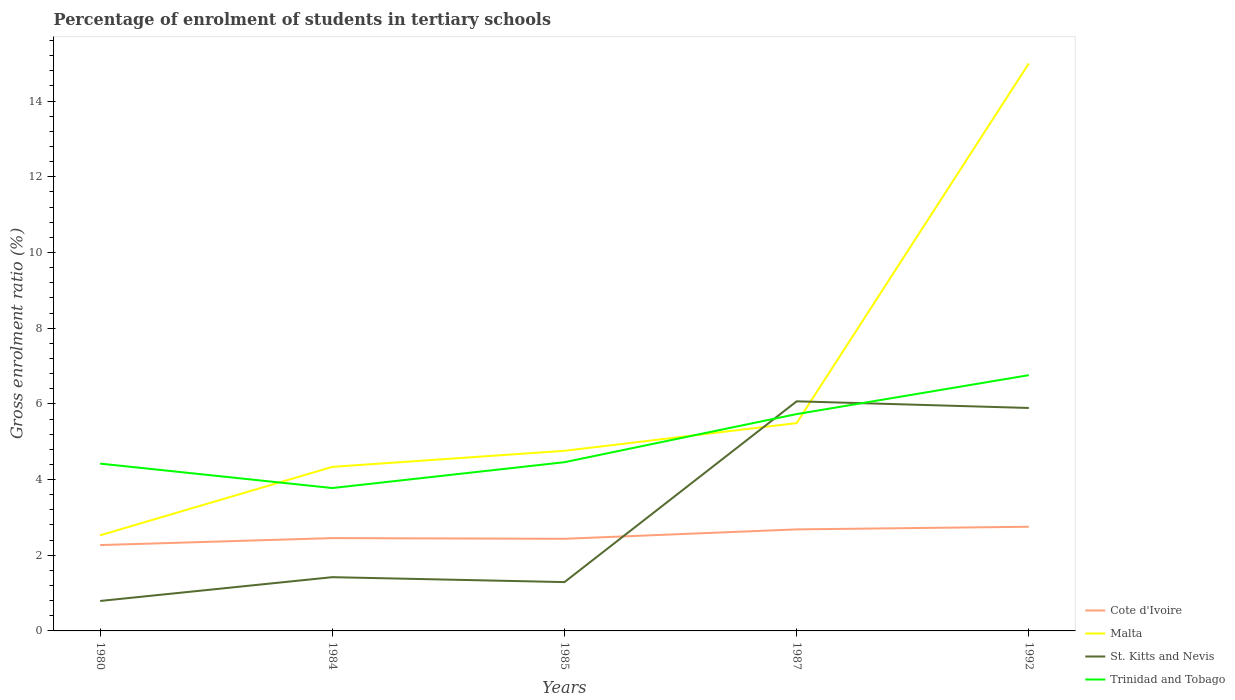How many different coloured lines are there?
Make the answer very short. 4. Does the line corresponding to St. Kitts and Nevis intersect with the line corresponding to Trinidad and Tobago?
Your answer should be very brief. Yes. Across all years, what is the maximum percentage of students enrolled in tertiary schools in St. Kitts and Nevis?
Your answer should be compact. 0.79. In which year was the percentage of students enrolled in tertiary schools in Trinidad and Tobago maximum?
Make the answer very short. 1984. What is the total percentage of students enrolled in tertiary schools in Cote d'Ivoire in the graph?
Provide a short and direct response. -0.18. What is the difference between the highest and the second highest percentage of students enrolled in tertiary schools in St. Kitts and Nevis?
Your answer should be compact. 5.28. What is the difference between the highest and the lowest percentage of students enrolled in tertiary schools in Trinidad and Tobago?
Make the answer very short. 2. How many lines are there?
Your response must be concise. 4. What is the difference between two consecutive major ticks on the Y-axis?
Your answer should be compact. 2. Does the graph contain any zero values?
Offer a very short reply. No. Does the graph contain grids?
Ensure brevity in your answer.  No. How many legend labels are there?
Provide a short and direct response. 4. How are the legend labels stacked?
Your answer should be compact. Vertical. What is the title of the graph?
Offer a terse response. Percentage of enrolment of students in tertiary schools. Does "Gabon" appear as one of the legend labels in the graph?
Give a very brief answer. No. What is the label or title of the X-axis?
Give a very brief answer. Years. What is the Gross enrolment ratio (%) of Cote d'Ivoire in 1980?
Give a very brief answer. 2.27. What is the Gross enrolment ratio (%) of Malta in 1980?
Provide a succinct answer. 2.53. What is the Gross enrolment ratio (%) of St. Kitts and Nevis in 1980?
Your answer should be compact. 0.79. What is the Gross enrolment ratio (%) in Trinidad and Tobago in 1980?
Ensure brevity in your answer.  4.42. What is the Gross enrolment ratio (%) in Cote d'Ivoire in 1984?
Give a very brief answer. 2.45. What is the Gross enrolment ratio (%) of Malta in 1984?
Ensure brevity in your answer.  4.33. What is the Gross enrolment ratio (%) of St. Kitts and Nevis in 1984?
Keep it short and to the point. 1.42. What is the Gross enrolment ratio (%) of Trinidad and Tobago in 1984?
Provide a succinct answer. 3.78. What is the Gross enrolment ratio (%) in Cote d'Ivoire in 1985?
Give a very brief answer. 2.43. What is the Gross enrolment ratio (%) of Malta in 1985?
Your response must be concise. 4.76. What is the Gross enrolment ratio (%) of St. Kitts and Nevis in 1985?
Provide a short and direct response. 1.29. What is the Gross enrolment ratio (%) in Trinidad and Tobago in 1985?
Your response must be concise. 4.46. What is the Gross enrolment ratio (%) of Cote d'Ivoire in 1987?
Keep it short and to the point. 2.68. What is the Gross enrolment ratio (%) of Malta in 1987?
Ensure brevity in your answer.  5.49. What is the Gross enrolment ratio (%) in St. Kitts and Nevis in 1987?
Keep it short and to the point. 6.07. What is the Gross enrolment ratio (%) of Trinidad and Tobago in 1987?
Provide a succinct answer. 5.73. What is the Gross enrolment ratio (%) in Cote d'Ivoire in 1992?
Offer a terse response. 2.75. What is the Gross enrolment ratio (%) in Malta in 1992?
Give a very brief answer. 15. What is the Gross enrolment ratio (%) of St. Kitts and Nevis in 1992?
Offer a very short reply. 5.89. What is the Gross enrolment ratio (%) of Trinidad and Tobago in 1992?
Your answer should be compact. 6.76. Across all years, what is the maximum Gross enrolment ratio (%) of Cote d'Ivoire?
Offer a terse response. 2.75. Across all years, what is the maximum Gross enrolment ratio (%) in Malta?
Offer a terse response. 15. Across all years, what is the maximum Gross enrolment ratio (%) in St. Kitts and Nevis?
Give a very brief answer. 6.07. Across all years, what is the maximum Gross enrolment ratio (%) in Trinidad and Tobago?
Provide a succinct answer. 6.76. Across all years, what is the minimum Gross enrolment ratio (%) in Cote d'Ivoire?
Your answer should be compact. 2.27. Across all years, what is the minimum Gross enrolment ratio (%) in Malta?
Give a very brief answer. 2.53. Across all years, what is the minimum Gross enrolment ratio (%) in St. Kitts and Nevis?
Provide a succinct answer. 0.79. Across all years, what is the minimum Gross enrolment ratio (%) in Trinidad and Tobago?
Keep it short and to the point. 3.78. What is the total Gross enrolment ratio (%) of Cote d'Ivoire in the graph?
Provide a succinct answer. 12.59. What is the total Gross enrolment ratio (%) in Malta in the graph?
Your answer should be compact. 32.11. What is the total Gross enrolment ratio (%) in St. Kitts and Nevis in the graph?
Your answer should be very brief. 15.46. What is the total Gross enrolment ratio (%) in Trinidad and Tobago in the graph?
Your answer should be compact. 25.14. What is the difference between the Gross enrolment ratio (%) in Cote d'Ivoire in 1980 and that in 1984?
Give a very brief answer. -0.18. What is the difference between the Gross enrolment ratio (%) in Malta in 1980 and that in 1984?
Make the answer very short. -1.81. What is the difference between the Gross enrolment ratio (%) of St. Kitts and Nevis in 1980 and that in 1984?
Ensure brevity in your answer.  -0.63. What is the difference between the Gross enrolment ratio (%) of Trinidad and Tobago in 1980 and that in 1984?
Your answer should be very brief. 0.65. What is the difference between the Gross enrolment ratio (%) of Cote d'Ivoire in 1980 and that in 1985?
Your response must be concise. -0.17. What is the difference between the Gross enrolment ratio (%) in Malta in 1980 and that in 1985?
Give a very brief answer. -2.23. What is the difference between the Gross enrolment ratio (%) in St. Kitts and Nevis in 1980 and that in 1985?
Provide a succinct answer. -0.5. What is the difference between the Gross enrolment ratio (%) in Trinidad and Tobago in 1980 and that in 1985?
Ensure brevity in your answer.  -0.04. What is the difference between the Gross enrolment ratio (%) in Cote d'Ivoire in 1980 and that in 1987?
Give a very brief answer. -0.41. What is the difference between the Gross enrolment ratio (%) in Malta in 1980 and that in 1987?
Provide a succinct answer. -2.96. What is the difference between the Gross enrolment ratio (%) in St. Kitts and Nevis in 1980 and that in 1987?
Give a very brief answer. -5.28. What is the difference between the Gross enrolment ratio (%) of Trinidad and Tobago in 1980 and that in 1987?
Your answer should be very brief. -1.31. What is the difference between the Gross enrolment ratio (%) in Cote d'Ivoire in 1980 and that in 1992?
Make the answer very short. -0.48. What is the difference between the Gross enrolment ratio (%) in Malta in 1980 and that in 1992?
Offer a terse response. -12.47. What is the difference between the Gross enrolment ratio (%) of Trinidad and Tobago in 1980 and that in 1992?
Your answer should be compact. -2.34. What is the difference between the Gross enrolment ratio (%) in Cote d'Ivoire in 1984 and that in 1985?
Offer a very short reply. 0.02. What is the difference between the Gross enrolment ratio (%) of Malta in 1984 and that in 1985?
Ensure brevity in your answer.  -0.42. What is the difference between the Gross enrolment ratio (%) in St. Kitts and Nevis in 1984 and that in 1985?
Your answer should be very brief. 0.13. What is the difference between the Gross enrolment ratio (%) in Trinidad and Tobago in 1984 and that in 1985?
Your answer should be compact. -0.68. What is the difference between the Gross enrolment ratio (%) of Cote d'Ivoire in 1984 and that in 1987?
Keep it short and to the point. -0.23. What is the difference between the Gross enrolment ratio (%) in Malta in 1984 and that in 1987?
Your answer should be compact. -1.16. What is the difference between the Gross enrolment ratio (%) of St. Kitts and Nevis in 1984 and that in 1987?
Your answer should be compact. -4.65. What is the difference between the Gross enrolment ratio (%) of Trinidad and Tobago in 1984 and that in 1987?
Your answer should be very brief. -1.95. What is the difference between the Gross enrolment ratio (%) of Cote d'Ivoire in 1984 and that in 1992?
Ensure brevity in your answer.  -0.3. What is the difference between the Gross enrolment ratio (%) in Malta in 1984 and that in 1992?
Your answer should be very brief. -10.66. What is the difference between the Gross enrolment ratio (%) in St. Kitts and Nevis in 1984 and that in 1992?
Offer a terse response. -4.47. What is the difference between the Gross enrolment ratio (%) in Trinidad and Tobago in 1984 and that in 1992?
Ensure brevity in your answer.  -2.98. What is the difference between the Gross enrolment ratio (%) of Cote d'Ivoire in 1985 and that in 1987?
Ensure brevity in your answer.  -0.25. What is the difference between the Gross enrolment ratio (%) in Malta in 1985 and that in 1987?
Ensure brevity in your answer.  -0.73. What is the difference between the Gross enrolment ratio (%) in St. Kitts and Nevis in 1985 and that in 1987?
Offer a terse response. -4.78. What is the difference between the Gross enrolment ratio (%) of Trinidad and Tobago in 1985 and that in 1987?
Provide a short and direct response. -1.27. What is the difference between the Gross enrolment ratio (%) of Cote d'Ivoire in 1985 and that in 1992?
Your response must be concise. -0.32. What is the difference between the Gross enrolment ratio (%) in Malta in 1985 and that in 1992?
Your response must be concise. -10.24. What is the difference between the Gross enrolment ratio (%) of St. Kitts and Nevis in 1985 and that in 1992?
Your response must be concise. -4.6. What is the difference between the Gross enrolment ratio (%) in Trinidad and Tobago in 1985 and that in 1992?
Keep it short and to the point. -2.3. What is the difference between the Gross enrolment ratio (%) of Cote d'Ivoire in 1987 and that in 1992?
Ensure brevity in your answer.  -0.07. What is the difference between the Gross enrolment ratio (%) of Malta in 1987 and that in 1992?
Your answer should be very brief. -9.5. What is the difference between the Gross enrolment ratio (%) in St. Kitts and Nevis in 1987 and that in 1992?
Provide a succinct answer. 0.18. What is the difference between the Gross enrolment ratio (%) in Trinidad and Tobago in 1987 and that in 1992?
Offer a very short reply. -1.03. What is the difference between the Gross enrolment ratio (%) of Cote d'Ivoire in 1980 and the Gross enrolment ratio (%) of Malta in 1984?
Keep it short and to the point. -2.07. What is the difference between the Gross enrolment ratio (%) in Cote d'Ivoire in 1980 and the Gross enrolment ratio (%) in St. Kitts and Nevis in 1984?
Provide a short and direct response. 0.85. What is the difference between the Gross enrolment ratio (%) of Cote d'Ivoire in 1980 and the Gross enrolment ratio (%) of Trinidad and Tobago in 1984?
Ensure brevity in your answer.  -1.51. What is the difference between the Gross enrolment ratio (%) in Malta in 1980 and the Gross enrolment ratio (%) in St. Kitts and Nevis in 1984?
Your response must be concise. 1.11. What is the difference between the Gross enrolment ratio (%) in Malta in 1980 and the Gross enrolment ratio (%) in Trinidad and Tobago in 1984?
Give a very brief answer. -1.25. What is the difference between the Gross enrolment ratio (%) of St. Kitts and Nevis in 1980 and the Gross enrolment ratio (%) of Trinidad and Tobago in 1984?
Keep it short and to the point. -2.98. What is the difference between the Gross enrolment ratio (%) of Cote d'Ivoire in 1980 and the Gross enrolment ratio (%) of Malta in 1985?
Your answer should be compact. -2.49. What is the difference between the Gross enrolment ratio (%) in Cote d'Ivoire in 1980 and the Gross enrolment ratio (%) in St. Kitts and Nevis in 1985?
Provide a short and direct response. 0.98. What is the difference between the Gross enrolment ratio (%) in Cote d'Ivoire in 1980 and the Gross enrolment ratio (%) in Trinidad and Tobago in 1985?
Offer a very short reply. -2.19. What is the difference between the Gross enrolment ratio (%) in Malta in 1980 and the Gross enrolment ratio (%) in St. Kitts and Nevis in 1985?
Offer a very short reply. 1.24. What is the difference between the Gross enrolment ratio (%) in Malta in 1980 and the Gross enrolment ratio (%) in Trinidad and Tobago in 1985?
Your answer should be compact. -1.93. What is the difference between the Gross enrolment ratio (%) in St. Kitts and Nevis in 1980 and the Gross enrolment ratio (%) in Trinidad and Tobago in 1985?
Your answer should be very brief. -3.67. What is the difference between the Gross enrolment ratio (%) of Cote d'Ivoire in 1980 and the Gross enrolment ratio (%) of Malta in 1987?
Your answer should be compact. -3.22. What is the difference between the Gross enrolment ratio (%) in Cote d'Ivoire in 1980 and the Gross enrolment ratio (%) in St. Kitts and Nevis in 1987?
Your response must be concise. -3.8. What is the difference between the Gross enrolment ratio (%) of Cote d'Ivoire in 1980 and the Gross enrolment ratio (%) of Trinidad and Tobago in 1987?
Offer a terse response. -3.46. What is the difference between the Gross enrolment ratio (%) of Malta in 1980 and the Gross enrolment ratio (%) of St. Kitts and Nevis in 1987?
Your response must be concise. -3.54. What is the difference between the Gross enrolment ratio (%) of Malta in 1980 and the Gross enrolment ratio (%) of Trinidad and Tobago in 1987?
Ensure brevity in your answer.  -3.2. What is the difference between the Gross enrolment ratio (%) of St. Kitts and Nevis in 1980 and the Gross enrolment ratio (%) of Trinidad and Tobago in 1987?
Your response must be concise. -4.94. What is the difference between the Gross enrolment ratio (%) of Cote d'Ivoire in 1980 and the Gross enrolment ratio (%) of Malta in 1992?
Your response must be concise. -12.73. What is the difference between the Gross enrolment ratio (%) in Cote d'Ivoire in 1980 and the Gross enrolment ratio (%) in St. Kitts and Nevis in 1992?
Make the answer very short. -3.62. What is the difference between the Gross enrolment ratio (%) of Cote d'Ivoire in 1980 and the Gross enrolment ratio (%) of Trinidad and Tobago in 1992?
Provide a succinct answer. -4.49. What is the difference between the Gross enrolment ratio (%) in Malta in 1980 and the Gross enrolment ratio (%) in St. Kitts and Nevis in 1992?
Ensure brevity in your answer.  -3.36. What is the difference between the Gross enrolment ratio (%) of Malta in 1980 and the Gross enrolment ratio (%) of Trinidad and Tobago in 1992?
Provide a succinct answer. -4.23. What is the difference between the Gross enrolment ratio (%) in St. Kitts and Nevis in 1980 and the Gross enrolment ratio (%) in Trinidad and Tobago in 1992?
Your answer should be very brief. -5.97. What is the difference between the Gross enrolment ratio (%) of Cote d'Ivoire in 1984 and the Gross enrolment ratio (%) of Malta in 1985?
Give a very brief answer. -2.31. What is the difference between the Gross enrolment ratio (%) of Cote d'Ivoire in 1984 and the Gross enrolment ratio (%) of St. Kitts and Nevis in 1985?
Your answer should be compact. 1.16. What is the difference between the Gross enrolment ratio (%) of Cote d'Ivoire in 1984 and the Gross enrolment ratio (%) of Trinidad and Tobago in 1985?
Make the answer very short. -2.01. What is the difference between the Gross enrolment ratio (%) in Malta in 1984 and the Gross enrolment ratio (%) in St. Kitts and Nevis in 1985?
Provide a short and direct response. 3.04. What is the difference between the Gross enrolment ratio (%) of Malta in 1984 and the Gross enrolment ratio (%) of Trinidad and Tobago in 1985?
Your answer should be compact. -0.12. What is the difference between the Gross enrolment ratio (%) of St. Kitts and Nevis in 1984 and the Gross enrolment ratio (%) of Trinidad and Tobago in 1985?
Provide a succinct answer. -3.04. What is the difference between the Gross enrolment ratio (%) of Cote d'Ivoire in 1984 and the Gross enrolment ratio (%) of Malta in 1987?
Make the answer very short. -3.04. What is the difference between the Gross enrolment ratio (%) of Cote d'Ivoire in 1984 and the Gross enrolment ratio (%) of St. Kitts and Nevis in 1987?
Your answer should be compact. -3.62. What is the difference between the Gross enrolment ratio (%) of Cote d'Ivoire in 1984 and the Gross enrolment ratio (%) of Trinidad and Tobago in 1987?
Give a very brief answer. -3.28. What is the difference between the Gross enrolment ratio (%) of Malta in 1984 and the Gross enrolment ratio (%) of St. Kitts and Nevis in 1987?
Your response must be concise. -1.73. What is the difference between the Gross enrolment ratio (%) of Malta in 1984 and the Gross enrolment ratio (%) of Trinidad and Tobago in 1987?
Your response must be concise. -1.39. What is the difference between the Gross enrolment ratio (%) in St. Kitts and Nevis in 1984 and the Gross enrolment ratio (%) in Trinidad and Tobago in 1987?
Your answer should be compact. -4.31. What is the difference between the Gross enrolment ratio (%) of Cote d'Ivoire in 1984 and the Gross enrolment ratio (%) of Malta in 1992?
Provide a short and direct response. -12.54. What is the difference between the Gross enrolment ratio (%) of Cote d'Ivoire in 1984 and the Gross enrolment ratio (%) of St. Kitts and Nevis in 1992?
Offer a very short reply. -3.44. What is the difference between the Gross enrolment ratio (%) of Cote d'Ivoire in 1984 and the Gross enrolment ratio (%) of Trinidad and Tobago in 1992?
Provide a short and direct response. -4.31. What is the difference between the Gross enrolment ratio (%) of Malta in 1984 and the Gross enrolment ratio (%) of St. Kitts and Nevis in 1992?
Provide a succinct answer. -1.56. What is the difference between the Gross enrolment ratio (%) in Malta in 1984 and the Gross enrolment ratio (%) in Trinidad and Tobago in 1992?
Offer a very short reply. -2.42. What is the difference between the Gross enrolment ratio (%) of St. Kitts and Nevis in 1984 and the Gross enrolment ratio (%) of Trinidad and Tobago in 1992?
Your answer should be compact. -5.34. What is the difference between the Gross enrolment ratio (%) of Cote d'Ivoire in 1985 and the Gross enrolment ratio (%) of Malta in 1987?
Offer a very short reply. -3.06. What is the difference between the Gross enrolment ratio (%) in Cote d'Ivoire in 1985 and the Gross enrolment ratio (%) in St. Kitts and Nevis in 1987?
Provide a succinct answer. -3.63. What is the difference between the Gross enrolment ratio (%) of Cote d'Ivoire in 1985 and the Gross enrolment ratio (%) of Trinidad and Tobago in 1987?
Your answer should be very brief. -3.3. What is the difference between the Gross enrolment ratio (%) in Malta in 1985 and the Gross enrolment ratio (%) in St. Kitts and Nevis in 1987?
Offer a very short reply. -1.31. What is the difference between the Gross enrolment ratio (%) of Malta in 1985 and the Gross enrolment ratio (%) of Trinidad and Tobago in 1987?
Give a very brief answer. -0.97. What is the difference between the Gross enrolment ratio (%) in St. Kitts and Nevis in 1985 and the Gross enrolment ratio (%) in Trinidad and Tobago in 1987?
Your response must be concise. -4.44. What is the difference between the Gross enrolment ratio (%) of Cote d'Ivoire in 1985 and the Gross enrolment ratio (%) of Malta in 1992?
Make the answer very short. -12.56. What is the difference between the Gross enrolment ratio (%) of Cote d'Ivoire in 1985 and the Gross enrolment ratio (%) of St. Kitts and Nevis in 1992?
Your answer should be compact. -3.46. What is the difference between the Gross enrolment ratio (%) of Cote d'Ivoire in 1985 and the Gross enrolment ratio (%) of Trinidad and Tobago in 1992?
Offer a very short reply. -4.32. What is the difference between the Gross enrolment ratio (%) of Malta in 1985 and the Gross enrolment ratio (%) of St. Kitts and Nevis in 1992?
Your response must be concise. -1.13. What is the difference between the Gross enrolment ratio (%) in Malta in 1985 and the Gross enrolment ratio (%) in Trinidad and Tobago in 1992?
Make the answer very short. -2. What is the difference between the Gross enrolment ratio (%) of St. Kitts and Nevis in 1985 and the Gross enrolment ratio (%) of Trinidad and Tobago in 1992?
Keep it short and to the point. -5.47. What is the difference between the Gross enrolment ratio (%) of Cote d'Ivoire in 1987 and the Gross enrolment ratio (%) of Malta in 1992?
Provide a short and direct response. -12.31. What is the difference between the Gross enrolment ratio (%) of Cote d'Ivoire in 1987 and the Gross enrolment ratio (%) of St. Kitts and Nevis in 1992?
Give a very brief answer. -3.21. What is the difference between the Gross enrolment ratio (%) in Cote d'Ivoire in 1987 and the Gross enrolment ratio (%) in Trinidad and Tobago in 1992?
Provide a short and direct response. -4.08. What is the difference between the Gross enrolment ratio (%) in Malta in 1987 and the Gross enrolment ratio (%) in St. Kitts and Nevis in 1992?
Offer a very short reply. -0.4. What is the difference between the Gross enrolment ratio (%) of Malta in 1987 and the Gross enrolment ratio (%) of Trinidad and Tobago in 1992?
Make the answer very short. -1.27. What is the difference between the Gross enrolment ratio (%) of St. Kitts and Nevis in 1987 and the Gross enrolment ratio (%) of Trinidad and Tobago in 1992?
Your answer should be compact. -0.69. What is the average Gross enrolment ratio (%) of Cote d'Ivoire per year?
Make the answer very short. 2.52. What is the average Gross enrolment ratio (%) of Malta per year?
Provide a succinct answer. 6.42. What is the average Gross enrolment ratio (%) of St. Kitts and Nevis per year?
Offer a very short reply. 3.09. What is the average Gross enrolment ratio (%) of Trinidad and Tobago per year?
Ensure brevity in your answer.  5.03. In the year 1980, what is the difference between the Gross enrolment ratio (%) of Cote d'Ivoire and Gross enrolment ratio (%) of Malta?
Make the answer very short. -0.26. In the year 1980, what is the difference between the Gross enrolment ratio (%) in Cote d'Ivoire and Gross enrolment ratio (%) in St. Kitts and Nevis?
Your answer should be very brief. 1.48. In the year 1980, what is the difference between the Gross enrolment ratio (%) of Cote d'Ivoire and Gross enrolment ratio (%) of Trinidad and Tobago?
Offer a very short reply. -2.15. In the year 1980, what is the difference between the Gross enrolment ratio (%) of Malta and Gross enrolment ratio (%) of St. Kitts and Nevis?
Provide a short and direct response. 1.74. In the year 1980, what is the difference between the Gross enrolment ratio (%) of Malta and Gross enrolment ratio (%) of Trinidad and Tobago?
Your answer should be very brief. -1.89. In the year 1980, what is the difference between the Gross enrolment ratio (%) in St. Kitts and Nevis and Gross enrolment ratio (%) in Trinidad and Tobago?
Ensure brevity in your answer.  -3.63. In the year 1984, what is the difference between the Gross enrolment ratio (%) in Cote d'Ivoire and Gross enrolment ratio (%) in Malta?
Provide a short and direct response. -1.88. In the year 1984, what is the difference between the Gross enrolment ratio (%) in Cote d'Ivoire and Gross enrolment ratio (%) in St. Kitts and Nevis?
Keep it short and to the point. 1.03. In the year 1984, what is the difference between the Gross enrolment ratio (%) of Cote d'Ivoire and Gross enrolment ratio (%) of Trinidad and Tobago?
Your answer should be compact. -1.32. In the year 1984, what is the difference between the Gross enrolment ratio (%) in Malta and Gross enrolment ratio (%) in St. Kitts and Nevis?
Offer a very short reply. 2.91. In the year 1984, what is the difference between the Gross enrolment ratio (%) of Malta and Gross enrolment ratio (%) of Trinidad and Tobago?
Your answer should be compact. 0.56. In the year 1984, what is the difference between the Gross enrolment ratio (%) in St. Kitts and Nevis and Gross enrolment ratio (%) in Trinidad and Tobago?
Provide a succinct answer. -2.36. In the year 1985, what is the difference between the Gross enrolment ratio (%) of Cote d'Ivoire and Gross enrolment ratio (%) of Malta?
Provide a short and direct response. -2.33. In the year 1985, what is the difference between the Gross enrolment ratio (%) of Cote d'Ivoire and Gross enrolment ratio (%) of St. Kitts and Nevis?
Your answer should be compact. 1.14. In the year 1985, what is the difference between the Gross enrolment ratio (%) of Cote d'Ivoire and Gross enrolment ratio (%) of Trinidad and Tobago?
Give a very brief answer. -2.02. In the year 1985, what is the difference between the Gross enrolment ratio (%) of Malta and Gross enrolment ratio (%) of St. Kitts and Nevis?
Offer a very short reply. 3.47. In the year 1985, what is the difference between the Gross enrolment ratio (%) of Malta and Gross enrolment ratio (%) of Trinidad and Tobago?
Your response must be concise. 0.3. In the year 1985, what is the difference between the Gross enrolment ratio (%) in St. Kitts and Nevis and Gross enrolment ratio (%) in Trinidad and Tobago?
Your answer should be compact. -3.17. In the year 1987, what is the difference between the Gross enrolment ratio (%) of Cote d'Ivoire and Gross enrolment ratio (%) of Malta?
Keep it short and to the point. -2.81. In the year 1987, what is the difference between the Gross enrolment ratio (%) in Cote d'Ivoire and Gross enrolment ratio (%) in St. Kitts and Nevis?
Give a very brief answer. -3.38. In the year 1987, what is the difference between the Gross enrolment ratio (%) of Cote d'Ivoire and Gross enrolment ratio (%) of Trinidad and Tobago?
Your answer should be very brief. -3.05. In the year 1987, what is the difference between the Gross enrolment ratio (%) in Malta and Gross enrolment ratio (%) in St. Kitts and Nevis?
Offer a very short reply. -0.58. In the year 1987, what is the difference between the Gross enrolment ratio (%) of Malta and Gross enrolment ratio (%) of Trinidad and Tobago?
Offer a terse response. -0.24. In the year 1987, what is the difference between the Gross enrolment ratio (%) in St. Kitts and Nevis and Gross enrolment ratio (%) in Trinidad and Tobago?
Your answer should be very brief. 0.34. In the year 1992, what is the difference between the Gross enrolment ratio (%) in Cote d'Ivoire and Gross enrolment ratio (%) in Malta?
Your answer should be very brief. -12.24. In the year 1992, what is the difference between the Gross enrolment ratio (%) of Cote d'Ivoire and Gross enrolment ratio (%) of St. Kitts and Nevis?
Offer a very short reply. -3.14. In the year 1992, what is the difference between the Gross enrolment ratio (%) of Cote d'Ivoire and Gross enrolment ratio (%) of Trinidad and Tobago?
Provide a succinct answer. -4.01. In the year 1992, what is the difference between the Gross enrolment ratio (%) of Malta and Gross enrolment ratio (%) of St. Kitts and Nevis?
Ensure brevity in your answer.  9.1. In the year 1992, what is the difference between the Gross enrolment ratio (%) of Malta and Gross enrolment ratio (%) of Trinidad and Tobago?
Provide a succinct answer. 8.24. In the year 1992, what is the difference between the Gross enrolment ratio (%) of St. Kitts and Nevis and Gross enrolment ratio (%) of Trinidad and Tobago?
Provide a short and direct response. -0.87. What is the ratio of the Gross enrolment ratio (%) of Cote d'Ivoire in 1980 to that in 1984?
Make the answer very short. 0.92. What is the ratio of the Gross enrolment ratio (%) in Malta in 1980 to that in 1984?
Offer a very short reply. 0.58. What is the ratio of the Gross enrolment ratio (%) of St. Kitts and Nevis in 1980 to that in 1984?
Offer a very short reply. 0.56. What is the ratio of the Gross enrolment ratio (%) in Trinidad and Tobago in 1980 to that in 1984?
Give a very brief answer. 1.17. What is the ratio of the Gross enrolment ratio (%) in Cote d'Ivoire in 1980 to that in 1985?
Make the answer very short. 0.93. What is the ratio of the Gross enrolment ratio (%) in Malta in 1980 to that in 1985?
Offer a very short reply. 0.53. What is the ratio of the Gross enrolment ratio (%) in St. Kitts and Nevis in 1980 to that in 1985?
Your response must be concise. 0.61. What is the ratio of the Gross enrolment ratio (%) in Trinidad and Tobago in 1980 to that in 1985?
Your answer should be very brief. 0.99. What is the ratio of the Gross enrolment ratio (%) of Cote d'Ivoire in 1980 to that in 1987?
Keep it short and to the point. 0.85. What is the ratio of the Gross enrolment ratio (%) in Malta in 1980 to that in 1987?
Offer a very short reply. 0.46. What is the ratio of the Gross enrolment ratio (%) of St. Kitts and Nevis in 1980 to that in 1987?
Make the answer very short. 0.13. What is the ratio of the Gross enrolment ratio (%) in Trinidad and Tobago in 1980 to that in 1987?
Your answer should be compact. 0.77. What is the ratio of the Gross enrolment ratio (%) of Cote d'Ivoire in 1980 to that in 1992?
Give a very brief answer. 0.82. What is the ratio of the Gross enrolment ratio (%) in Malta in 1980 to that in 1992?
Make the answer very short. 0.17. What is the ratio of the Gross enrolment ratio (%) of St. Kitts and Nevis in 1980 to that in 1992?
Offer a terse response. 0.13. What is the ratio of the Gross enrolment ratio (%) in Trinidad and Tobago in 1980 to that in 1992?
Make the answer very short. 0.65. What is the ratio of the Gross enrolment ratio (%) of Cote d'Ivoire in 1984 to that in 1985?
Offer a very short reply. 1.01. What is the ratio of the Gross enrolment ratio (%) in Malta in 1984 to that in 1985?
Offer a terse response. 0.91. What is the ratio of the Gross enrolment ratio (%) of St. Kitts and Nevis in 1984 to that in 1985?
Keep it short and to the point. 1.1. What is the ratio of the Gross enrolment ratio (%) of Trinidad and Tobago in 1984 to that in 1985?
Provide a short and direct response. 0.85. What is the ratio of the Gross enrolment ratio (%) of Cote d'Ivoire in 1984 to that in 1987?
Provide a short and direct response. 0.91. What is the ratio of the Gross enrolment ratio (%) of Malta in 1984 to that in 1987?
Provide a short and direct response. 0.79. What is the ratio of the Gross enrolment ratio (%) in St. Kitts and Nevis in 1984 to that in 1987?
Offer a very short reply. 0.23. What is the ratio of the Gross enrolment ratio (%) in Trinidad and Tobago in 1984 to that in 1987?
Offer a very short reply. 0.66. What is the ratio of the Gross enrolment ratio (%) of Cote d'Ivoire in 1984 to that in 1992?
Your answer should be very brief. 0.89. What is the ratio of the Gross enrolment ratio (%) in Malta in 1984 to that in 1992?
Your answer should be very brief. 0.29. What is the ratio of the Gross enrolment ratio (%) of St. Kitts and Nevis in 1984 to that in 1992?
Make the answer very short. 0.24. What is the ratio of the Gross enrolment ratio (%) of Trinidad and Tobago in 1984 to that in 1992?
Give a very brief answer. 0.56. What is the ratio of the Gross enrolment ratio (%) in Cote d'Ivoire in 1985 to that in 1987?
Ensure brevity in your answer.  0.91. What is the ratio of the Gross enrolment ratio (%) in Malta in 1985 to that in 1987?
Provide a short and direct response. 0.87. What is the ratio of the Gross enrolment ratio (%) in St. Kitts and Nevis in 1985 to that in 1987?
Your response must be concise. 0.21. What is the ratio of the Gross enrolment ratio (%) of Trinidad and Tobago in 1985 to that in 1987?
Your answer should be compact. 0.78. What is the ratio of the Gross enrolment ratio (%) in Cote d'Ivoire in 1985 to that in 1992?
Keep it short and to the point. 0.88. What is the ratio of the Gross enrolment ratio (%) of Malta in 1985 to that in 1992?
Give a very brief answer. 0.32. What is the ratio of the Gross enrolment ratio (%) of St. Kitts and Nevis in 1985 to that in 1992?
Your answer should be compact. 0.22. What is the ratio of the Gross enrolment ratio (%) of Trinidad and Tobago in 1985 to that in 1992?
Provide a succinct answer. 0.66. What is the ratio of the Gross enrolment ratio (%) of Cote d'Ivoire in 1987 to that in 1992?
Provide a short and direct response. 0.97. What is the ratio of the Gross enrolment ratio (%) of Malta in 1987 to that in 1992?
Keep it short and to the point. 0.37. What is the ratio of the Gross enrolment ratio (%) in St. Kitts and Nevis in 1987 to that in 1992?
Your answer should be very brief. 1.03. What is the ratio of the Gross enrolment ratio (%) in Trinidad and Tobago in 1987 to that in 1992?
Make the answer very short. 0.85. What is the difference between the highest and the second highest Gross enrolment ratio (%) of Cote d'Ivoire?
Offer a very short reply. 0.07. What is the difference between the highest and the second highest Gross enrolment ratio (%) of Malta?
Make the answer very short. 9.5. What is the difference between the highest and the second highest Gross enrolment ratio (%) in St. Kitts and Nevis?
Offer a terse response. 0.18. What is the difference between the highest and the second highest Gross enrolment ratio (%) of Trinidad and Tobago?
Your answer should be very brief. 1.03. What is the difference between the highest and the lowest Gross enrolment ratio (%) in Cote d'Ivoire?
Your answer should be compact. 0.48. What is the difference between the highest and the lowest Gross enrolment ratio (%) in Malta?
Give a very brief answer. 12.47. What is the difference between the highest and the lowest Gross enrolment ratio (%) of St. Kitts and Nevis?
Provide a short and direct response. 5.28. What is the difference between the highest and the lowest Gross enrolment ratio (%) in Trinidad and Tobago?
Give a very brief answer. 2.98. 